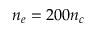Convert formula to latex. <formula><loc_0><loc_0><loc_500><loc_500>n _ { e } = 2 0 0 n _ { c }</formula> 